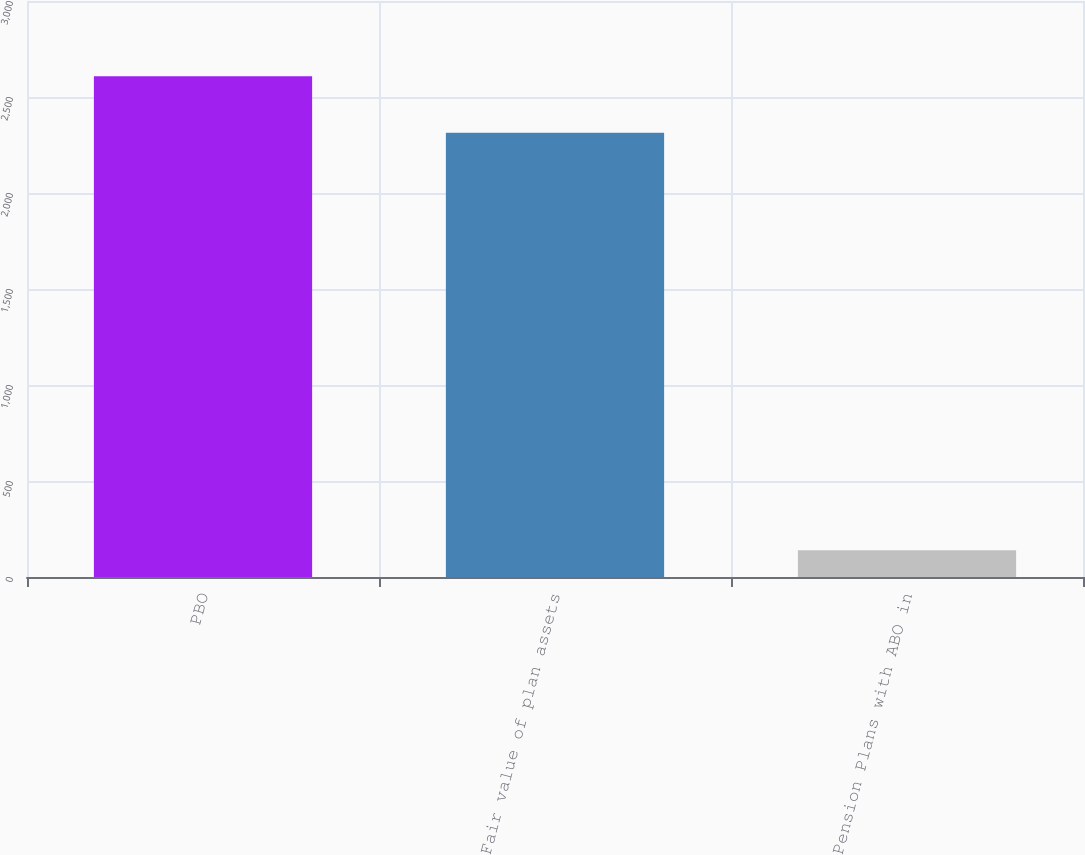<chart> <loc_0><loc_0><loc_500><loc_500><bar_chart><fcel>PBO<fcel>Fair value of plan assets<fcel>Pension Plans with ABO in<nl><fcel>2607.6<fcel>2313.4<fcel>139.3<nl></chart> 